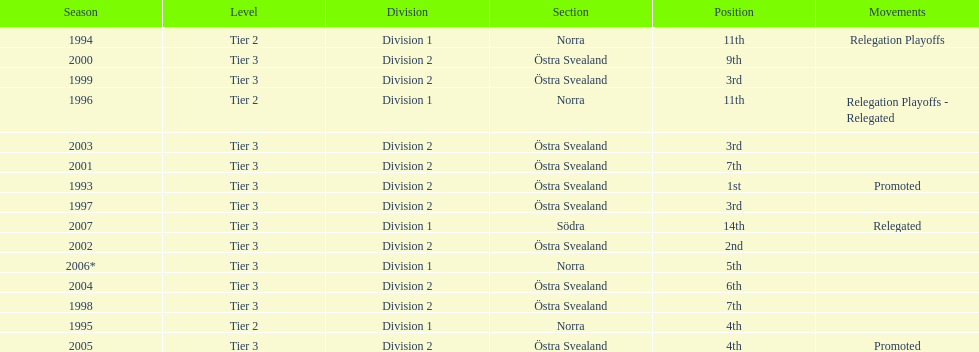In 2000 they finished 9th in their division, did they perform better or worse the next season? Better. 